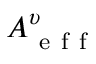<formula> <loc_0><loc_0><loc_500><loc_500>A _ { e f f } ^ { \upsilon }</formula> 